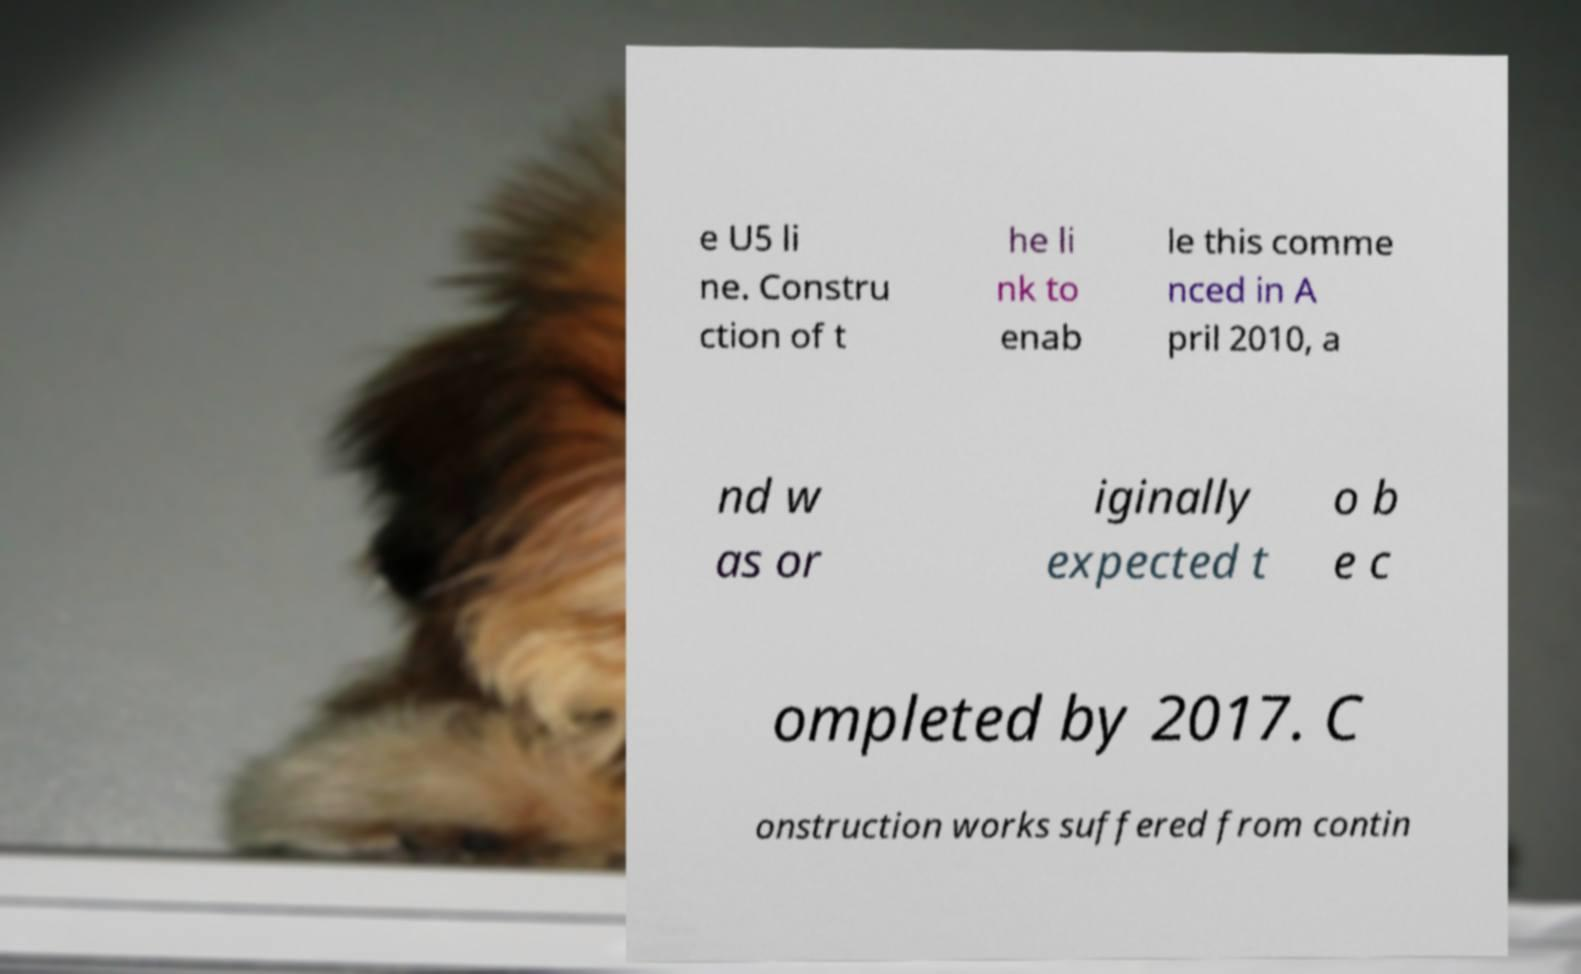Please read and relay the text visible in this image. What does it say? e U5 li ne. Constru ction of t he li nk to enab le this comme nced in A pril 2010, a nd w as or iginally expected t o b e c ompleted by 2017. C onstruction works suffered from contin 